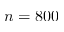<formula> <loc_0><loc_0><loc_500><loc_500>n = 8 0 0</formula> 